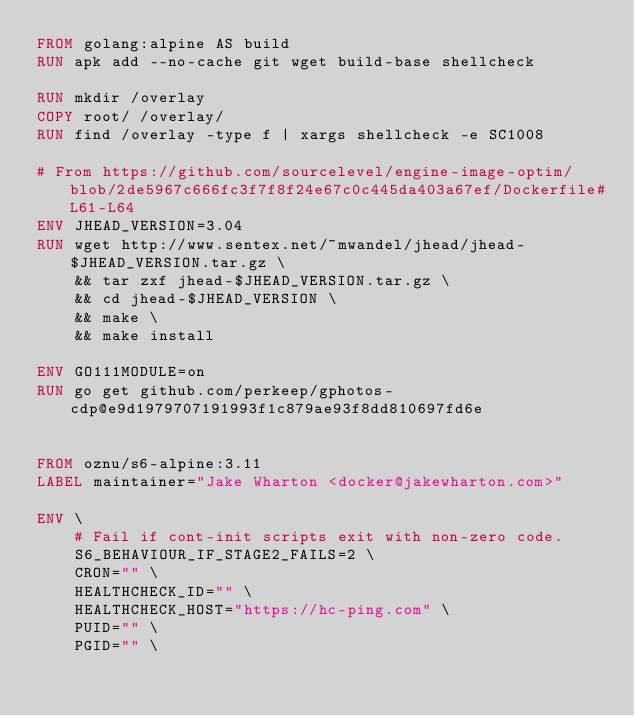Convert code to text. <code><loc_0><loc_0><loc_500><loc_500><_Dockerfile_>FROM golang:alpine AS build
RUN apk add --no-cache git wget build-base shellcheck

RUN mkdir /overlay
COPY root/ /overlay/
RUN find /overlay -type f | xargs shellcheck -e SC1008

# From https://github.com/sourcelevel/engine-image-optim/blob/2de5967c666fc3f7f8f24e67c0c445da403a67ef/Dockerfile#L61-L64
ENV JHEAD_VERSION=3.04
RUN wget http://www.sentex.net/~mwandel/jhead/jhead-$JHEAD_VERSION.tar.gz \
    && tar zxf jhead-$JHEAD_VERSION.tar.gz \
    && cd jhead-$JHEAD_VERSION \
    && make \
    && make install

ENV GO111MODULE=on
RUN go get github.com/perkeep/gphotos-cdp@e9d1979707191993f1c879ae93f8dd810697fd6e


FROM oznu/s6-alpine:3.11
LABEL maintainer="Jake Wharton <docker@jakewharton.com>"

ENV \
    # Fail if cont-init scripts exit with non-zero code.
    S6_BEHAVIOUR_IF_STAGE2_FAILS=2 \
    CRON="" \
    HEALTHCHECK_ID="" \
    HEALTHCHECK_HOST="https://hc-ping.com" \
    PUID="" \
    PGID="" \</code> 